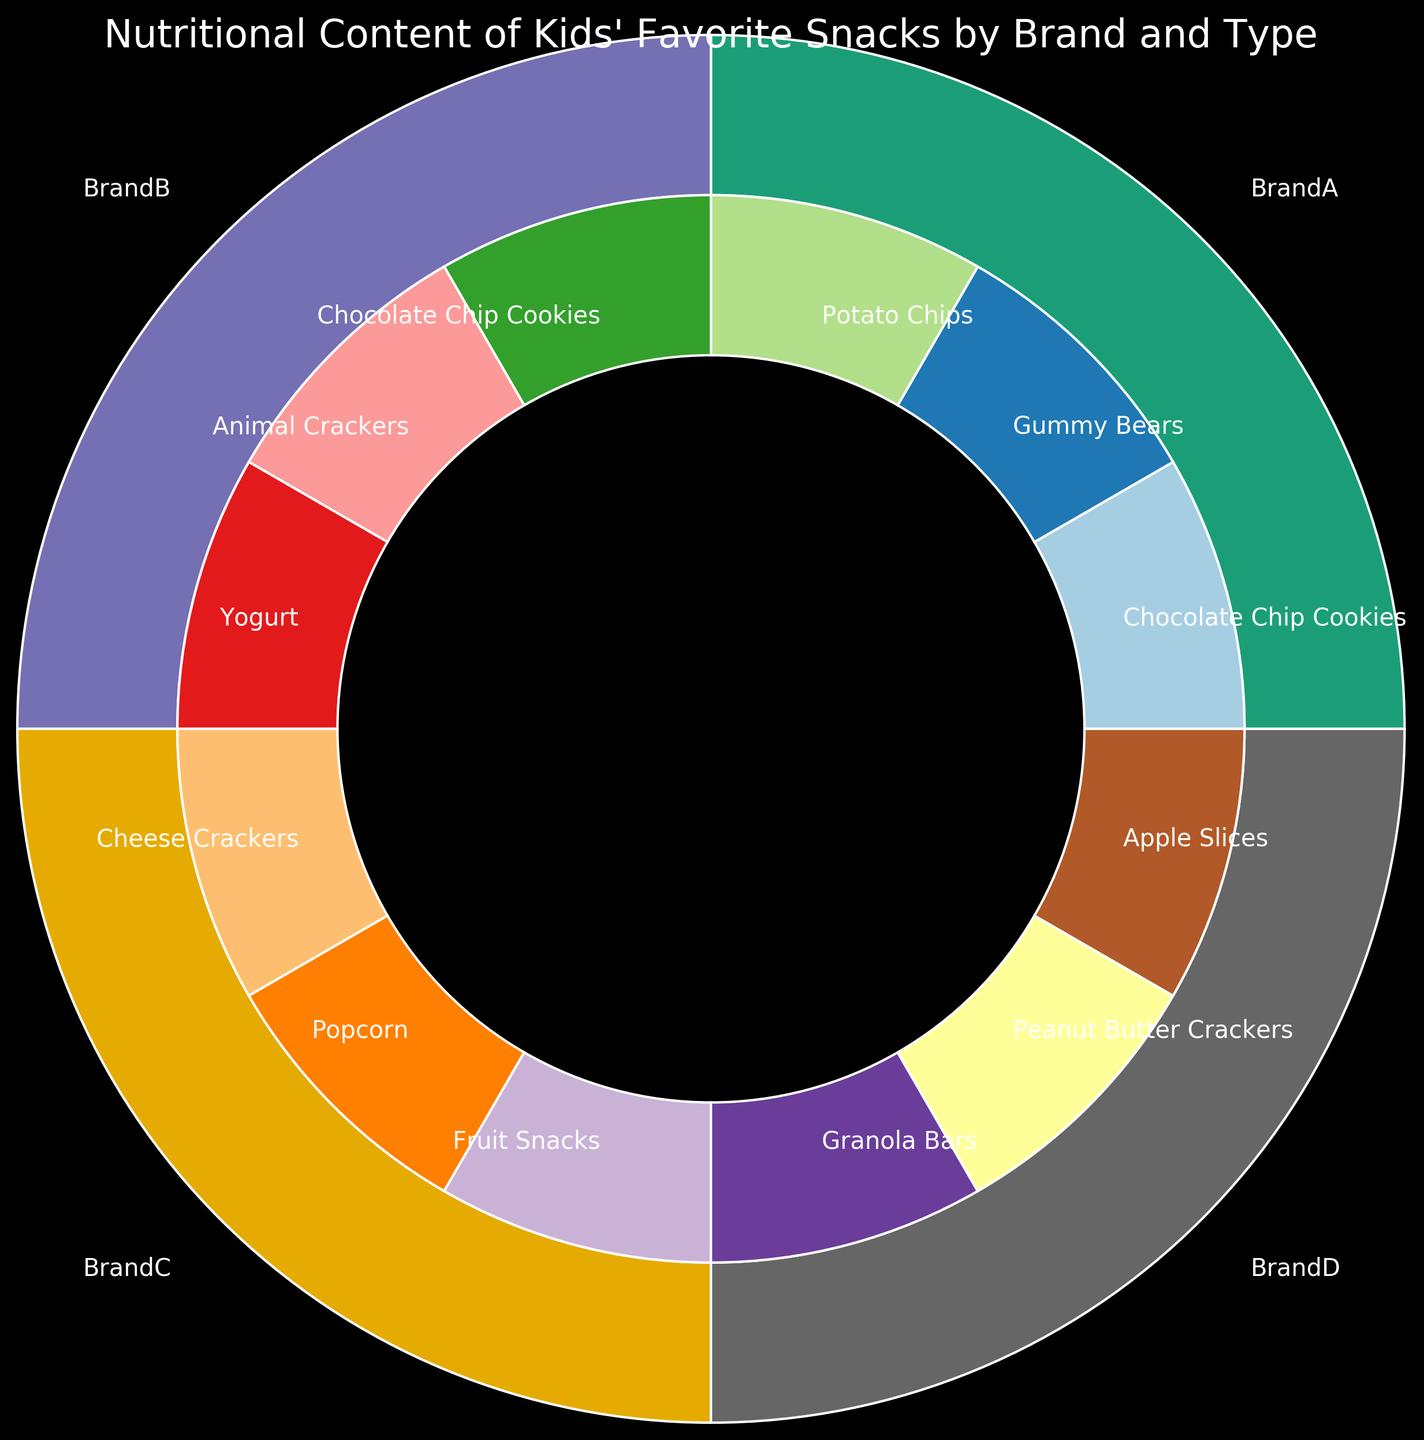What's the most common snack type from Brand C? To determine the most common snack type for Brand C, look at the inner ring of the pie chart where it intersects with Brand C's section in the outer ring. Count the snack types and see which one appears the most often.
Answer: Cheese Crackers Which brand offers the snack with the lowest sugar content? Look for the brands in the outer ring and identify the section of the inner ring corresponding to snacks with the least sugar content by visually comparing the sugar amounts listed.
Answer: Brand C Which brand has the widest variety of snack types? Examine the outer ring for each brand, then count the number of distinct snack types (inner ring segments) within each brand’s section. The brand with the most types has the widest variety.
Answer: Brand D Between Brand A and Brand B, which brand's snacks have, on average, more sugar content? Find all the snack types belonging to Brand A and Brand B. Sum the sugar content for each brand, then divide by the number of their respective snacks to get the average. Compare these averages.
Answer: Brand A What visual attribute identifies the snack types within each brand? Look at how the inner segments are differentiated from each other within each brand’s section. Identify the visual trait used.
Answer: Color Which snack type appears exclusively in one brand? Check across all brand sections in the inner ring to see which snack type is only listed once across the figure.
Answer: Fruit Snacks How many snack types contain between 125 and 175 calories? Identify the calorie content listed for each snack type in the inner ring and count how many fall within the specified range.
Answer: 5 Which brand's section contains the most diverse color range in the inner ring? Visually inspect the inner segments of each brand’s section for the variety of colors used. Compare to see which brand has the most distinct colors.
Answer: Brand D Compare the total fat content offered by Brand B and Brand D. Which offers snacks with higher total fat content? Add the fat content values for all snack types within Brand B, and then do the same for Brand D. Compare the summed values.
Answer: Brand D What's the average protein content of snacks from Brand B? Sum the protein content for all snack types within Brand B. Divide this total by the number of snack types offered by Brand B to get the average.
Answer: 3 